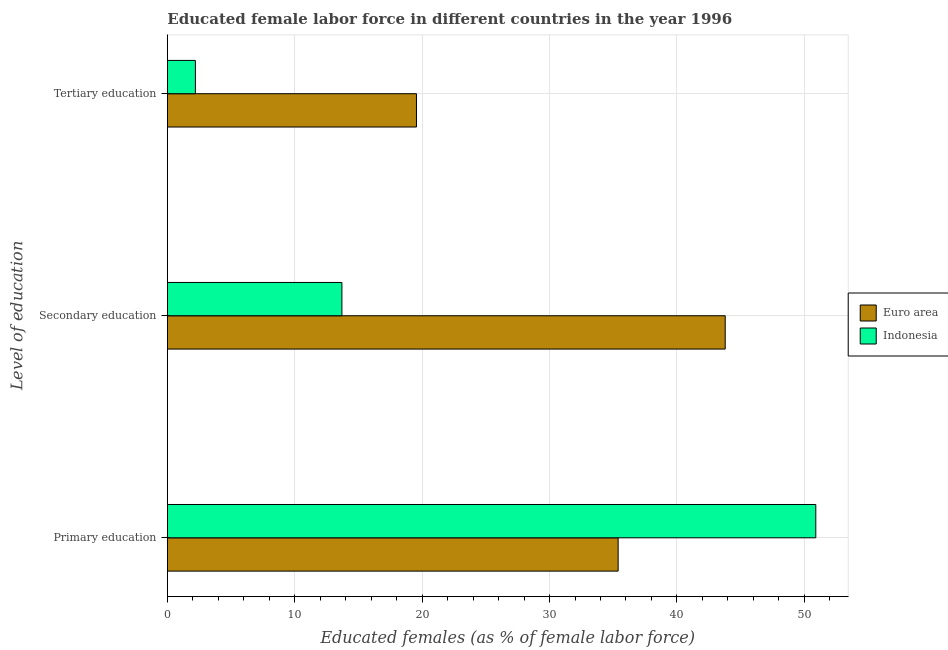Are the number of bars on each tick of the Y-axis equal?
Your answer should be very brief. Yes. How many bars are there on the 2nd tick from the bottom?
Your answer should be compact. 2. What is the label of the 2nd group of bars from the top?
Your answer should be compact. Secondary education. What is the percentage of female labor force who received primary education in Euro area?
Give a very brief answer. 35.38. Across all countries, what is the maximum percentage of female labor force who received primary education?
Your answer should be very brief. 50.9. Across all countries, what is the minimum percentage of female labor force who received secondary education?
Your answer should be compact. 13.7. In which country was the percentage of female labor force who received primary education maximum?
Give a very brief answer. Indonesia. In which country was the percentage of female labor force who received tertiary education minimum?
Give a very brief answer. Indonesia. What is the total percentage of female labor force who received tertiary education in the graph?
Provide a succinct answer. 21.75. What is the difference between the percentage of female labor force who received primary education in Euro area and that in Indonesia?
Provide a short and direct response. -15.52. What is the difference between the percentage of female labor force who received secondary education in Euro area and the percentage of female labor force who received tertiary education in Indonesia?
Give a very brief answer. 41.59. What is the average percentage of female labor force who received primary education per country?
Provide a succinct answer. 43.14. What is the difference between the percentage of female labor force who received tertiary education and percentage of female labor force who received primary education in Euro area?
Make the answer very short. -15.83. What is the ratio of the percentage of female labor force who received primary education in Euro area to that in Indonesia?
Provide a short and direct response. 0.7. What is the difference between the highest and the second highest percentage of female labor force who received primary education?
Your answer should be very brief. 15.52. What is the difference between the highest and the lowest percentage of female labor force who received primary education?
Give a very brief answer. 15.52. In how many countries, is the percentage of female labor force who received tertiary education greater than the average percentage of female labor force who received tertiary education taken over all countries?
Your response must be concise. 1. What does the 2nd bar from the top in Tertiary education represents?
Provide a short and direct response. Euro area. How many bars are there?
Give a very brief answer. 6. Are all the bars in the graph horizontal?
Your answer should be compact. Yes. What is the difference between two consecutive major ticks on the X-axis?
Keep it short and to the point. 10. Does the graph contain grids?
Your answer should be very brief. Yes. What is the title of the graph?
Your answer should be compact. Educated female labor force in different countries in the year 1996. Does "Sudan" appear as one of the legend labels in the graph?
Offer a terse response. No. What is the label or title of the X-axis?
Offer a very short reply. Educated females (as % of female labor force). What is the label or title of the Y-axis?
Provide a succinct answer. Level of education. What is the Educated females (as % of female labor force) of Euro area in Primary education?
Offer a very short reply. 35.38. What is the Educated females (as % of female labor force) of Indonesia in Primary education?
Give a very brief answer. 50.9. What is the Educated females (as % of female labor force) of Euro area in Secondary education?
Provide a succinct answer. 43.79. What is the Educated females (as % of female labor force) in Indonesia in Secondary education?
Keep it short and to the point. 13.7. What is the Educated females (as % of female labor force) of Euro area in Tertiary education?
Your answer should be compact. 19.55. What is the Educated females (as % of female labor force) of Indonesia in Tertiary education?
Offer a very short reply. 2.2. Across all Level of education, what is the maximum Educated females (as % of female labor force) of Euro area?
Offer a very short reply. 43.79. Across all Level of education, what is the maximum Educated females (as % of female labor force) in Indonesia?
Provide a succinct answer. 50.9. Across all Level of education, what is the minimum Educated females (as % of female labor force) in Euro area?
Offer a very short reply. 19.55. Across all Level of education, what is the minimum Educated females (as % of female labor force) of Indonesia?
Offer a terse response. 2.2. What is the total Educated females (as % of female labor force) in Euro area in the graph?
Your answer should be very brief. 98.73. What is the total Educated females (as % of female labor force) of Indonesia in the graph?
Provide a short and direct response. 66.8. What is the difference between the Educated females (as % of female labor force) in Euro area in Primary education and that in Secondary education?
Your response must be concise. -8.4. What is the difference between the Educated females (as % of female labor force) of Indonesia in Primary education and that in Secondary education?
Give a very brief answer. 37.2. What is the difference between the Educated females (as % of female labor force) of Euro area in Primary education and that in Tertiary education?
Offer a very short reply. 15.83. What is the difference between the Educated females (as % of female labor force) in Indonesia in Primary education and that in Tertiary education?
Your answer should be compact. 48.7. What is the difference between the Educated females (as % of female labor force) in Euro area in Secondary education and that in Tertiary education?
Provide a short and direct response. 24.23. What is the difference between the Educated females (as % of female labor force) in Indonesia in Secondary education and that in Tertiary education?
Provide a succinct answer. 11.5. What is the difference between the Educated females (as % of female labor force) of Euro area in Primary education and the Educated females (as % of female labor force) of Indonesia in Secondary education?
Provide a short and direct response. 21.68. What is the difference between the Educated females (as % of female labor force) of Euro area in Primary education and the Educated females (as % of female labor force) of Indonesia in Tertiary education?
Offer a very short reply. 33.18. What is the difference between the Educated females (as % of female labor force) in Euro area in Secondary education and the Educated females (as % of female labor force) in Indonesia in Tertiary education?
Provide a succinct answer. 41.59. What is the average Educated females (as % of female labor force) of Euro area per Level of education?
Offer a very short reply. 32.91. What is the average Educated females (as % of female labor force) of Indonesia per Level of education?
Offer a very short reply. 22.27. What is the difference between the Educated females (as % of female labor force) in Euro area and Educated females (as % of female labor force) in Indonesia in Primary education?
Keep it short and to the point. -15.52. What is the difference between the Educated females (as % of female labor force) in Euro area and Educated females (as % of female labor force) in Indonesia in Secondary education?
Your answer should be compact. 30.09. What is the difference between the Educated females (as % of female labor force) in Euro area and Educated females (as % of female labor force) in Indonesia in Tertiary education?
Keep it short and to the point. 17.35. What is the ratio of the Educated females (as % of female labor force) in Euro area in Primary education to that in Secondary education?
Give a very brief answer. 0.81. What is the ratio of the Educated females (as % of female labor force) of Indonesia in Primary education to that in Secondary education?
Your response must be concise. 3.72. What is the ratio of the Educated females (as % of female labor force) of Euro area in Primary education to that in Tertiary education?
Make the answer very short. 1.81. What is the ratio of the Educated females (as % of female labor force) of Indonesia in Primary education to that in Tertiary education?
Ensure brevity in your answer.  23.14. What is the ratio of the Educated females (as % of female labor force) of Euro area in Secondary education to that in Tertiary education?
Provide a short and direct response. 2.24. What is the ratio of the Educated females (as % of female labor force) in Indonesia in Secondary education to that in Tertiary education?
Make the answer very short. 6.23. What is the difference between the highest and the second highest Educated females (as % of female labor force) of Euro area?
Offer a terse response. 8.4. What is the difference between the highest and the second highest Educated females (as % of female labor force) in Indonesia?
Ensure brevity in your answer.  37.2. What is the difference between the highest and the lowest Educated females (as % of female labor force) of Euro area?
Keep it short and to the point. 24.23. What is the difference between the highest and the lowest Educated females (as % of female labor force) in Indonesia?
Your response must be concise. 48.7. 